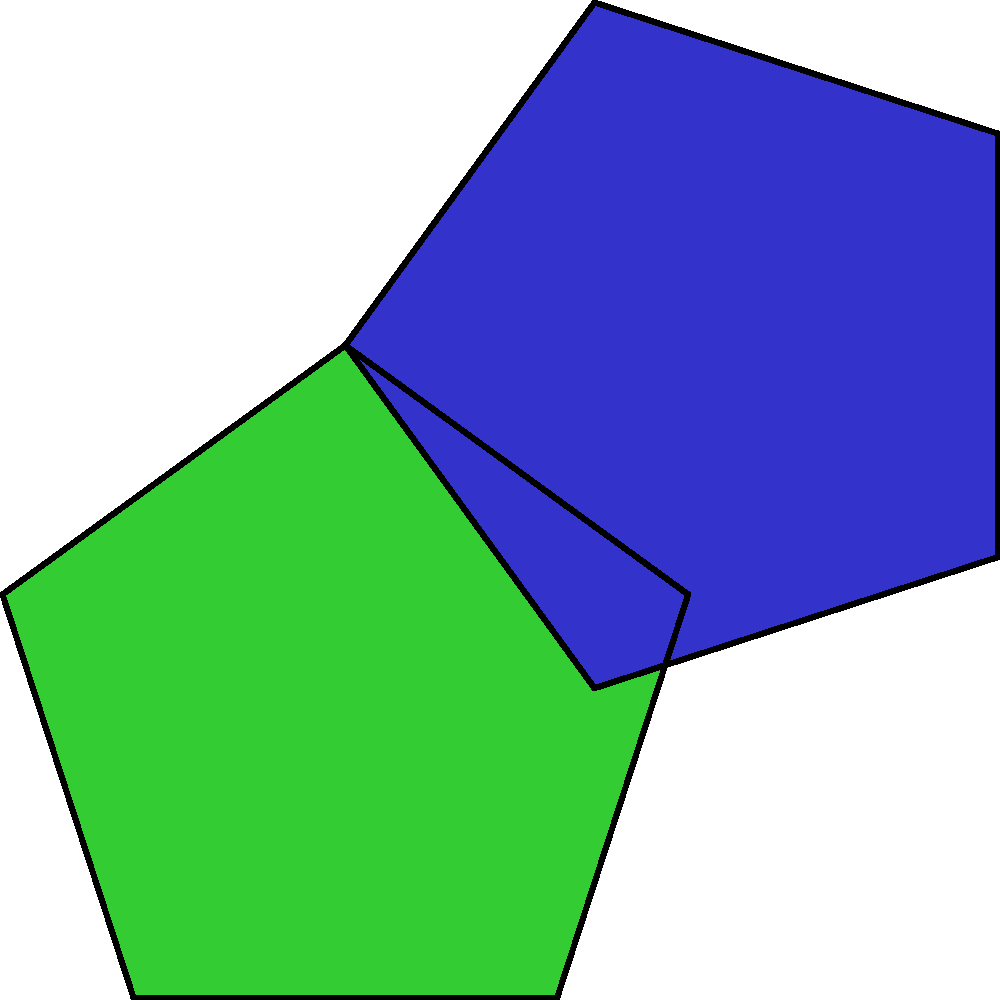In this abstract art pattern inspired by Anderson Delano Macklin's geometric style, three regular pentagons are shown. The red pentagon is the original shape. The green pentagon is obtained by rotating the red pentagon. The blue pentagon is obtained by reflecting the green pentagon. What is the angle of rotation (in degrees) between the red and green pentagons, and across which axis is the blue pentagon reflected? To solve this problem, let's analyze the transformations step by step:

1. Rotation from red to green pentagon:
   - Regular pentagons have 5 sides and 5 vertices.
   - The internal angle of a regular pentagon is $(540°/5) = 108°$.
   - The angle between two adjacent vertices from the center is $360°/5 = 72°$.
   - Observing the image, we can see that the green pentagon is rotated by one vertex position clockwise.
   - Therefore, the angle of rotation is $72°$.

2. Reflection of green to blue pentagon:
   - The blue pentagon appears to be a mirror image of the green pentagon.
   - The axis of reflection appears to be vertical.
   - In geometric terms, this is a reflection across the y-axis.

Thus, the green pentagon is rotated $72°$ clockwise from the red pentagon, and the blue pentagon is reflected across the y-axis from the green pentagon.
Answer: $72°$, y-axis 